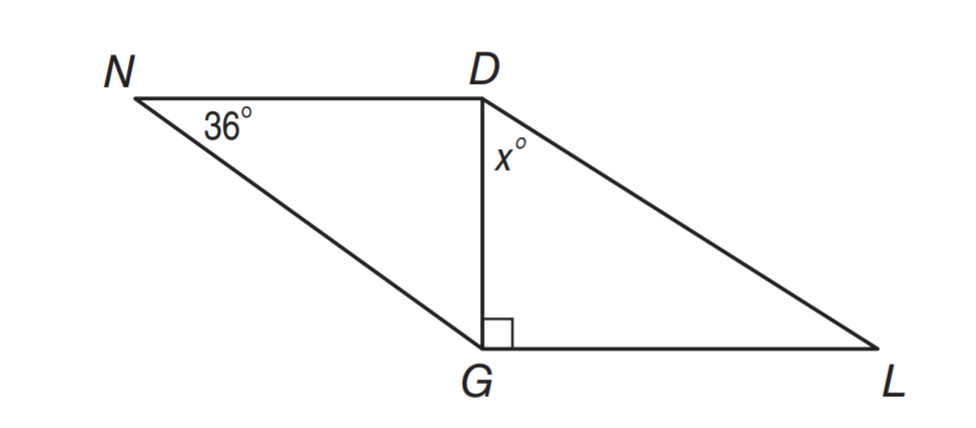Question: \triangle N D G \cong \triangle L G D. Find x.
Choices:
A. 36
B. 54
C. 60
D. 77
Answer with the letter. Answer: B 